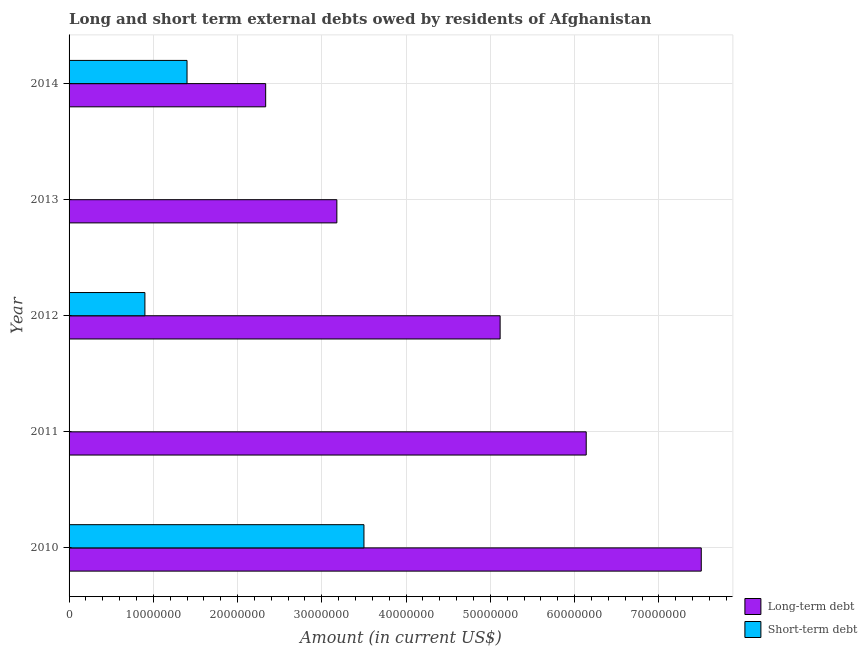How many different coloured bars are there?
Provide a succinct answer. 2. How many bars are there on the 5th tick from the top?
Offer a terse response. 2. In how many cases, is the number of bars for a given year not equal to the number of legend labels?
Your answer should be very brief. 2. What is the long-term debts owed by residents in 2010?
Your response must be concise. 7.50e+07. Across all years, what is the maximum short-term debts owed by residents?
Provide a short and direct response. 3.50e+07. Across all years, what is the minimum long-term debts owed by residents?
Your answer should be very brief. 2.33e+07. In which year was the long-term debts owed by residents maximum?
Provide a succinct answer. 2010. What is the total short-term debts owed by residents in the graph?
Your answer should be very brief. 5.80e+07. What is the difference between the long-term debts owed by residents in 2010 and that in 2013?
Offer a very short reply. 4.33e+07. What is the difference between the short-term debts owed by residents in 2013 and the long-term debts owed by residents in 2011?
Provide a succinct answer. -6.14e+07. What is the average long-term debts owed by residents per year?
Give a very brief answer. 4.85e+07. In the year 2010, what is the difference between the short-term debts owed by residents and long-term debts owed by residents?
Ensure brevity in your answer.  -4.00e+07. What is the ratio of the short-term debts owed by residents in 2012 to that in 2014?
Provide a succinct answer. 0.64. Is the long-term debts owed by residents in 2012 less than that in 2013?
Your answer should be compact. No. Is the difference between the long-term debts owed by residents in 2010 and 2014 greater than the difference between the short-term debts owed by residents in 2010 and 2014?
Make the answer very short. Yes. What is the difference between the highest and the second highest long-term debts owed by residents?
Your response must be concise. 1.37e+07. What is the difference between the highest and the lowest long-term debts owed by residents?
Your answer should be very brief. 5.17e+07. What is the difference between two consecutive major ticks on the X-axis?
Provide a succinct answer. 1.00e+07. Does the graph contain any zero values?
Your answer should be compact. Yes. Does the graph contain grids?
Your answer should be compact. Yes. Where does the legend appear in the graph?
Your answer should be very brief. Bottom right. How many legend labels are there?
Give a very brief answer. 2. What is the title of the graph?
Provide a succinct answer. Long and short term external debts owed by residents of Afghanistan. What is the label or title of the X-axis?
Your response must be concise. Amount (in current US$). What is the label or title of the Y-axis?
Make the answer very short. Year. What is the Amount (in current US$) of Long-term debt in 2010?
Provide a succinct answer. 7.50e+07. What is the Amount (in current US$) in Short-term debt in 2010?
Make the answer very short. 3.50e+07. What is the Amount (in current US$) in Long-term debt in 2011?
Your response must be concise. 6.14e+07. What is the Amount (in current US$) of Short-term debt in 2011?
Offer a very short reply. 0. What is the Amount (in current US$) of Long-term debt in 2012?
Provide a succinct answer. 5.12e+07. What is the Amount (in current US$) in Short-term debt in 2012?
Your response must be concise. 9.00e+06. What is the Amount (in current US$) in Long-term debt in 2013?
Make the answer very short. 3.18e+07. What is the Amount (in current US$) in Long-term debt in 2014?
Your response must be concise. 2.33e+07. What is the Amount (in current US$) in Short-term debt in 2014?
Your answer should be compact. 1.40e+07. Across all years, what is the maximum Amount (in current US$) in Long-term debt?
Keep it short and to the point. 7.50e+07. Across all years, what is the maximum Amount (in current US$) in Short-term debt?
Ensure brevity in your answer.  3.50e+07. Across all years, what is the minimum Amount (in current US$) in Long-term debt?
Offer a terse response. 2.33e+07. Across all years, what is the minimum Amount (in current US$) of Short-term debt?
Provide a short and direct response. 0. What is the total Amount (in current US$) of Long-term debt in the graph?
Keep it short and to the point. 2.43e+08. What is the total Amount (in current US$) in Short-term debt in the graph?
Your response must be concise. 5.80e+07. What is the difference between the Amount (in current US$) in Long-term debt in 2010 and that in 2011?
Make the answer very short. 1.37e+07. What is the difference between the Amount (in current US$) of Long-term debt in 2010 and that in 2012?
Keep it short and to the point. 2.39e+07. What is the difference between the Amount (in current US$) of Short-term debt in 2010 and that in 2012?
Provide a succinct answer. 2.60e+07. What is the difference between the Amount (in current US$) of Long-term debt in 2010 and that in 2013?
Provide a succinct answer. 4.33e+07. What is the difference between the Amount (in current US$) of Long-term debt in 2010 and that in 2014?
Provide a succinct answer. 5.17e+07. What is the difference between the Amount (in current US$) in Short-term debt in 2010 and that in 2014?
Provide a succinct answer. 2.10e+07. What is the difference between the Amount (in current US$) of Long-term debt in 2011 and that in 2012?
Provide a short and direct response. 1.02e+07. What is the difference between the Amount (in current US$) in Long-term debt in 2011 and that in 2013?
Provide a succinct answer. 2.96e+07. What is the difference between the Amount (in current US$) of Long-term debt in 2011 and that in 2014?
Give a very brief answer. 3.80e+07. What is the difference between the Amount (in current US$) in Long-term debt in 2012 and that in 2013?
Keep it short and to the point. 1.94e+07. What is the difference between the Amount (in current US$) of Long-term debt in 2012 and that in 2014?
Ensure brevity in your answer.  2.78e+07. What is the difference between the Amount (in current US$) in Short-term debt in 2012 and that in 2014?
Make the answer very short. -5.00e+06. What is the difference between the Amount (in current US$) in Long-term debt in 2013 and that in 2014?
Make the answer very short. 8.45e+06. What is the difference between the Amount (in current US$) of Long-term debt in 2010 and the Amount (in current US$) of Short-term debt in 2012?
Provide a succinct answer. 6.60e+07. What is the difference between the Amount (in current US$) of Long-term debt in 2010 and the Amount (in current US$) of Short-term debt in 2014?
Keep it short and to the point. 6.10e+07. What is the difference between the Amount (in current US$) in Long-term debt in 2011 and the Amount (in current US$) in Short-term debt in 2012?
Provide a succinct answer. 5.24e+07. What is the difference between the Amount (in current US$) in Long-term debt in 2011 and the Amount (in current US$) in Short-term debt in 2014?
Provide a short and direct response. 4.74e+07. What is the difference between the Amount (in current US$) in Long-term debt in 2012 and the Amount (in current US$) in Short-term debt in 2014?
Your response must be concise. 3.72e+07. What is the difference between the Amount (in current US$) in Long-term debt in 2013 and the Amount (in current US$) in Short-term debt in 2014?
Make the answer very short. 1.78e+07. What is the average Amount (in current US$) of Long-term debt per year?
Give a very brief answer. 4.85e+07. What is the average Amount (in current US$) in Short-term debt per year?
Your response must be concise. 1.16e+07. In the year 2010, what is the difference between the Amount (in current US$) of Long-term debt and Amount (in current US$) of Short-term debt?
Keep it short and to the point. 4.00e+07. In the year 2012, what is the difference between the Amount (in current US$) in Long-term debt and Amount (in current US$) in Short-term debt?
Provide a succinct answer. 4.22e+07. In the year 2014, what is the difference between the Amount (in current US$) of Long-term debt and Amount (in current US$) of Short-term debt?
Make the answer very short. 9.34e+06. What is the ratio of the Amount (in current US$) in Long-term debt in 2010 to that in 2011?
Your answer should be compact. 1.22. What is the ratio of the Amount (in current US$) in Long-term debt in 2010 to that in 2012?
Give a very brief answer. 1.47. What is the ratio of the Amount (in current US$) in Short-term debt in 2010 to that in 2012?
Provide a succinct answer. 3.89. What is the ratio of the Amount (in current US$) of Long-term debt in 2010 to that in 2013?
Provide a short and direct response. 2.36. What is the ratio of the Amount (in current US$) in Long-term debt in 2010 to that in 2014?
Offer a very short reply. 3.22. What is the ratio of the Amount (in current US$) in Short-term debt in 2010 to that in 2014?
Offer a terse response. 2.5. What is the ratio of the Amount (in current US$) of Long-term debt in 2011 to that in 2012?
Provide a short and direct response. 1.2. What is the ratio of the Amount (in current US$) in Long-term debt in 2011 to that in 2013?
Make the answer very short. 1.93. What is the ratio of the Amount (in current US$) of Long-term debt in 2011 to that in 2014?
Your answer should be compact. 2.63. What is the ratio of the Amount (in current US$) of Long-term debt in 2012 to that in 2013?
Your answer should be compact. 1.61. What is the ratio of the Amount (in current US$) in Long-term debt in 2012 to that in 2014?
Provide a short and direct response. 2.19. What is the ratio of the Amount (in current US$) of Short-term debt in 2012 to that in 2014?
Ensure brevity in your answer.  0.64. What is the ratio of the Amount (in current US$) of Long-term debt in 2013 to that in 2014?
Your answer should be very brief. 1.36. What is the difference between the highest and the second highest Amount (in current US$) of Long-term debt?
Your answer should be compact. 1.37e+07. What is the difference between the highest and the second highest Amount (in current US$) in Short-term debt?
Your answer should be very brief. 2.10e+07. What is the difference between the highest and the lowest Amount (in current US$) in Long-term debt?
Ensure brevity in your answer.  5.17e+07. What is the difference between the highest and the lowest Amount (in current US$) in Short-term debt?
Give a very brief answer. 3.50e+07. 